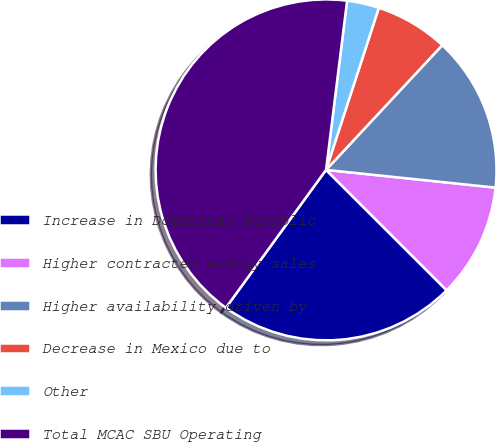Convert chart. <chart><loc_0><loc_0><loc_500><loc_500><pie_chart><fcel>Increase in Dominican Republic<fcel>Higher contracted energy sales<fcel>Higher availability driven by<fcel>Decrease in Mexico due to<fcel>Other<fcel>Total MCAC SBU Operating<nl><fcel>22.51%<fcel>10.83%<fcel>14.72%<fcel>6.93%<fcel>3.04%<fcel>41.97%<nl></chart> 